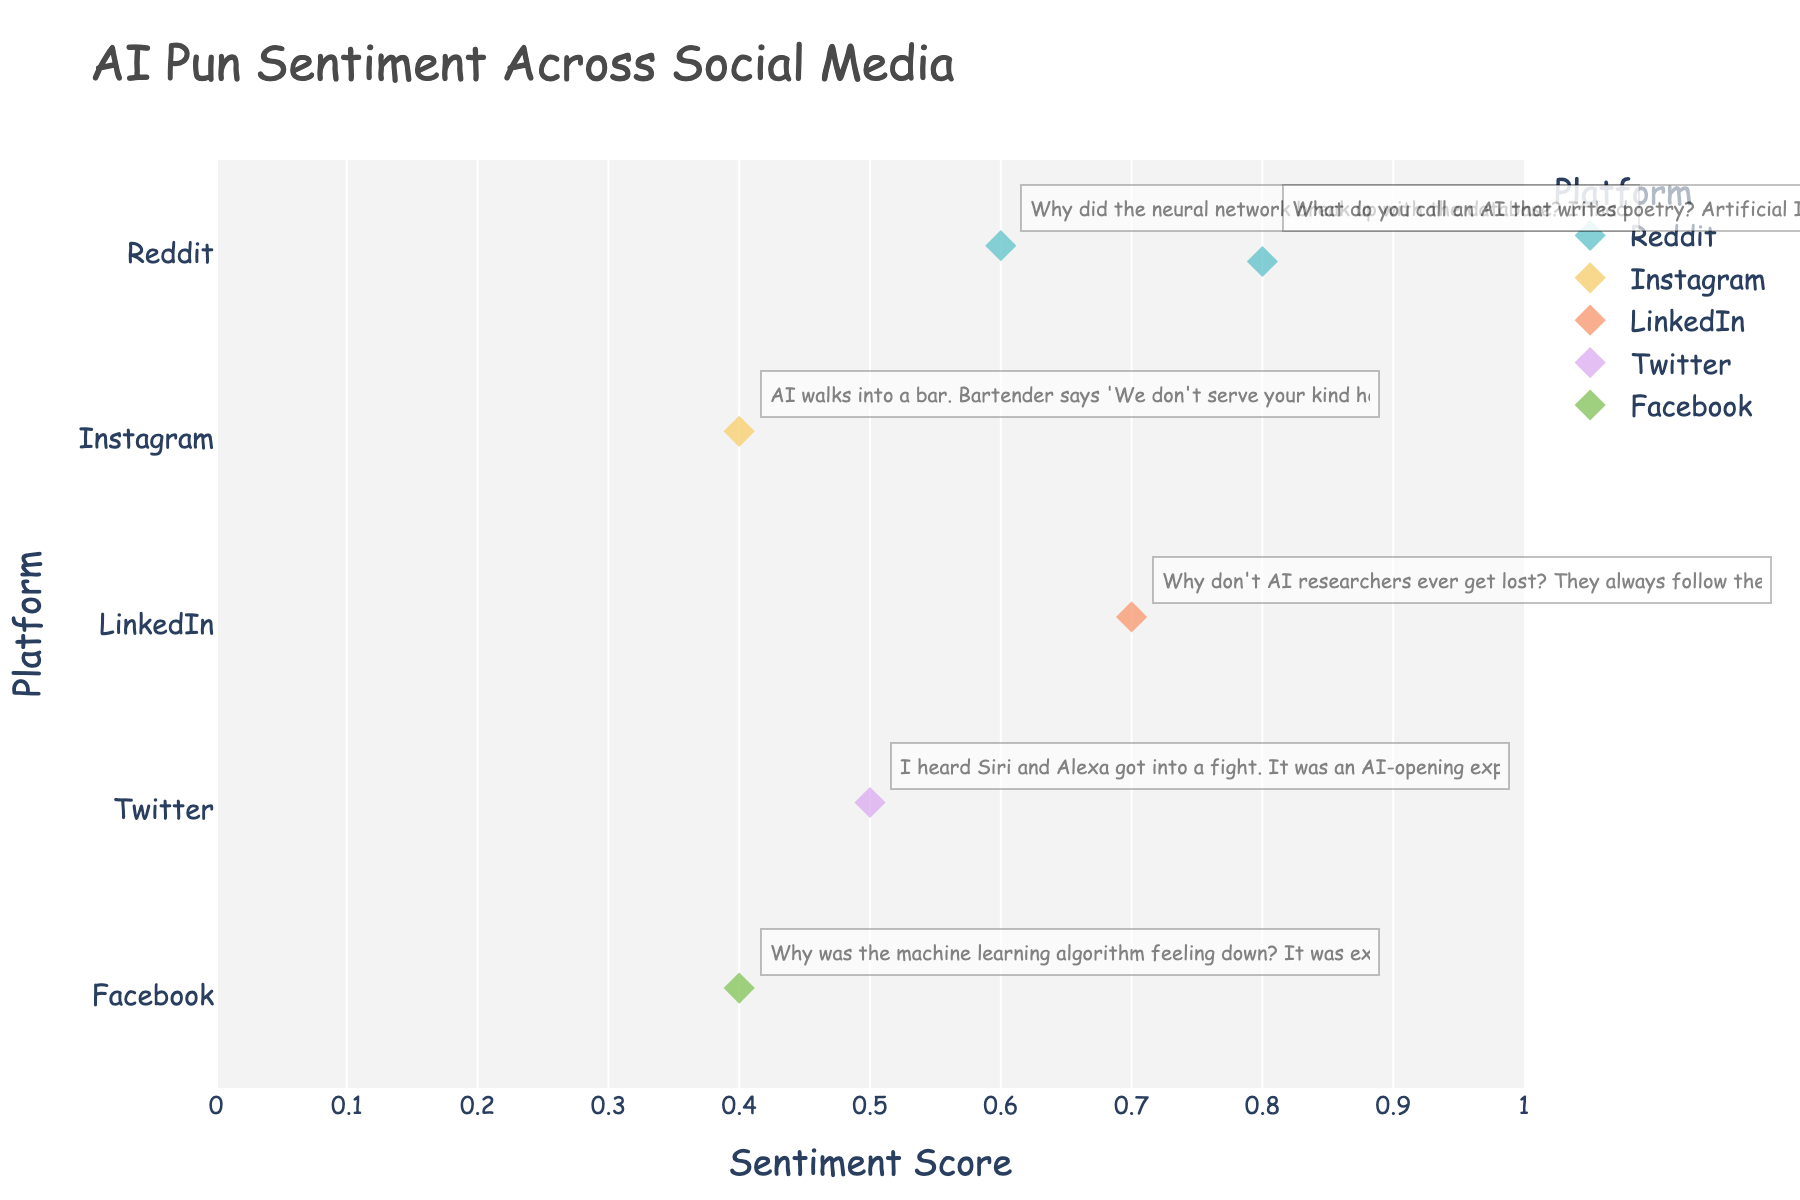What's the highest sentiment score on Reddit? Look for the highest sentiment score in the 'Reddit' row and see 'Artificial Intelligrhyme!' which has a score of 0.8
Answer: 0.8 Which platform features AI puns with both the lowest and the highest sentiment scores? Find the platform with data points corresponding to both the lowest sentiment score (0.4) and the highest sentiment score (0.8). Reddit meets these criteria with 'Artificial Intelligrhyme!' (0.8) and another pun.
Answer: Reddit How many AI puns on social media platforms have a sentiment score greater than 0.5? Count the number of data points with sentiment scores above 0.5. 'Reddit' mentioned twice and 'LinkedIn' mentioned have sentiment scores above 0.5.
Answer: 3 What's the average sentiment score of AI puns shared on Instagram and Facebook combined? Add the sentiment scores for Instagram (0.4) and Facebook (0.4), then divide by the number of puns, which is 2. (0.4 + 0.4)/2 = 0.4
Answer: 0.4 Which platform's AI-related puns have the median sentiment score of 0.5? List the sentiment scores for each platform, sort them, and locate the median value. The median score 0.5 corresponds to the pun on Twitter.
Answer: Twitter How does the sentiment score vary for puns on Reddit? Identify the sentiment scores on Reddit (0.6, 0.8) and analyze their spread: from 0.6 to 0.8.
Answer: From 0.6 to 0.8 Compare the sentiment score of the AI pun on LinkedIn with that on Facebook. Look at the sentiment scores of the LinkedIn pun (0.7) and the Facebook pun (0.4) and compare them: LinkedIn has a higher sentiment score than Facebook.
Answer: LinkedIn > Facebook What is the range of sentiment scores for the AI puns across all platforms? Find the difference between the highest sentiment score (0.8) and the lowest sentiment score (0.4). 0.8 - 0.4 = 0.4
Answer: 0.4 Which platform has the most consistent (least varied) sentiment scores for AI puns? Examine the sentiment scores for each platform and determine which has the least variation. Instagram and Facebook both have a single score, 0.4, meaning no variation.
Answer: Instagram and Facebook How many platforms have puns with sentiment scores below 0.5? Identify the platforms with puns scoring below 0.5. Instagram and Facebook each have one pun scoring 0.4.
Answer: 2 